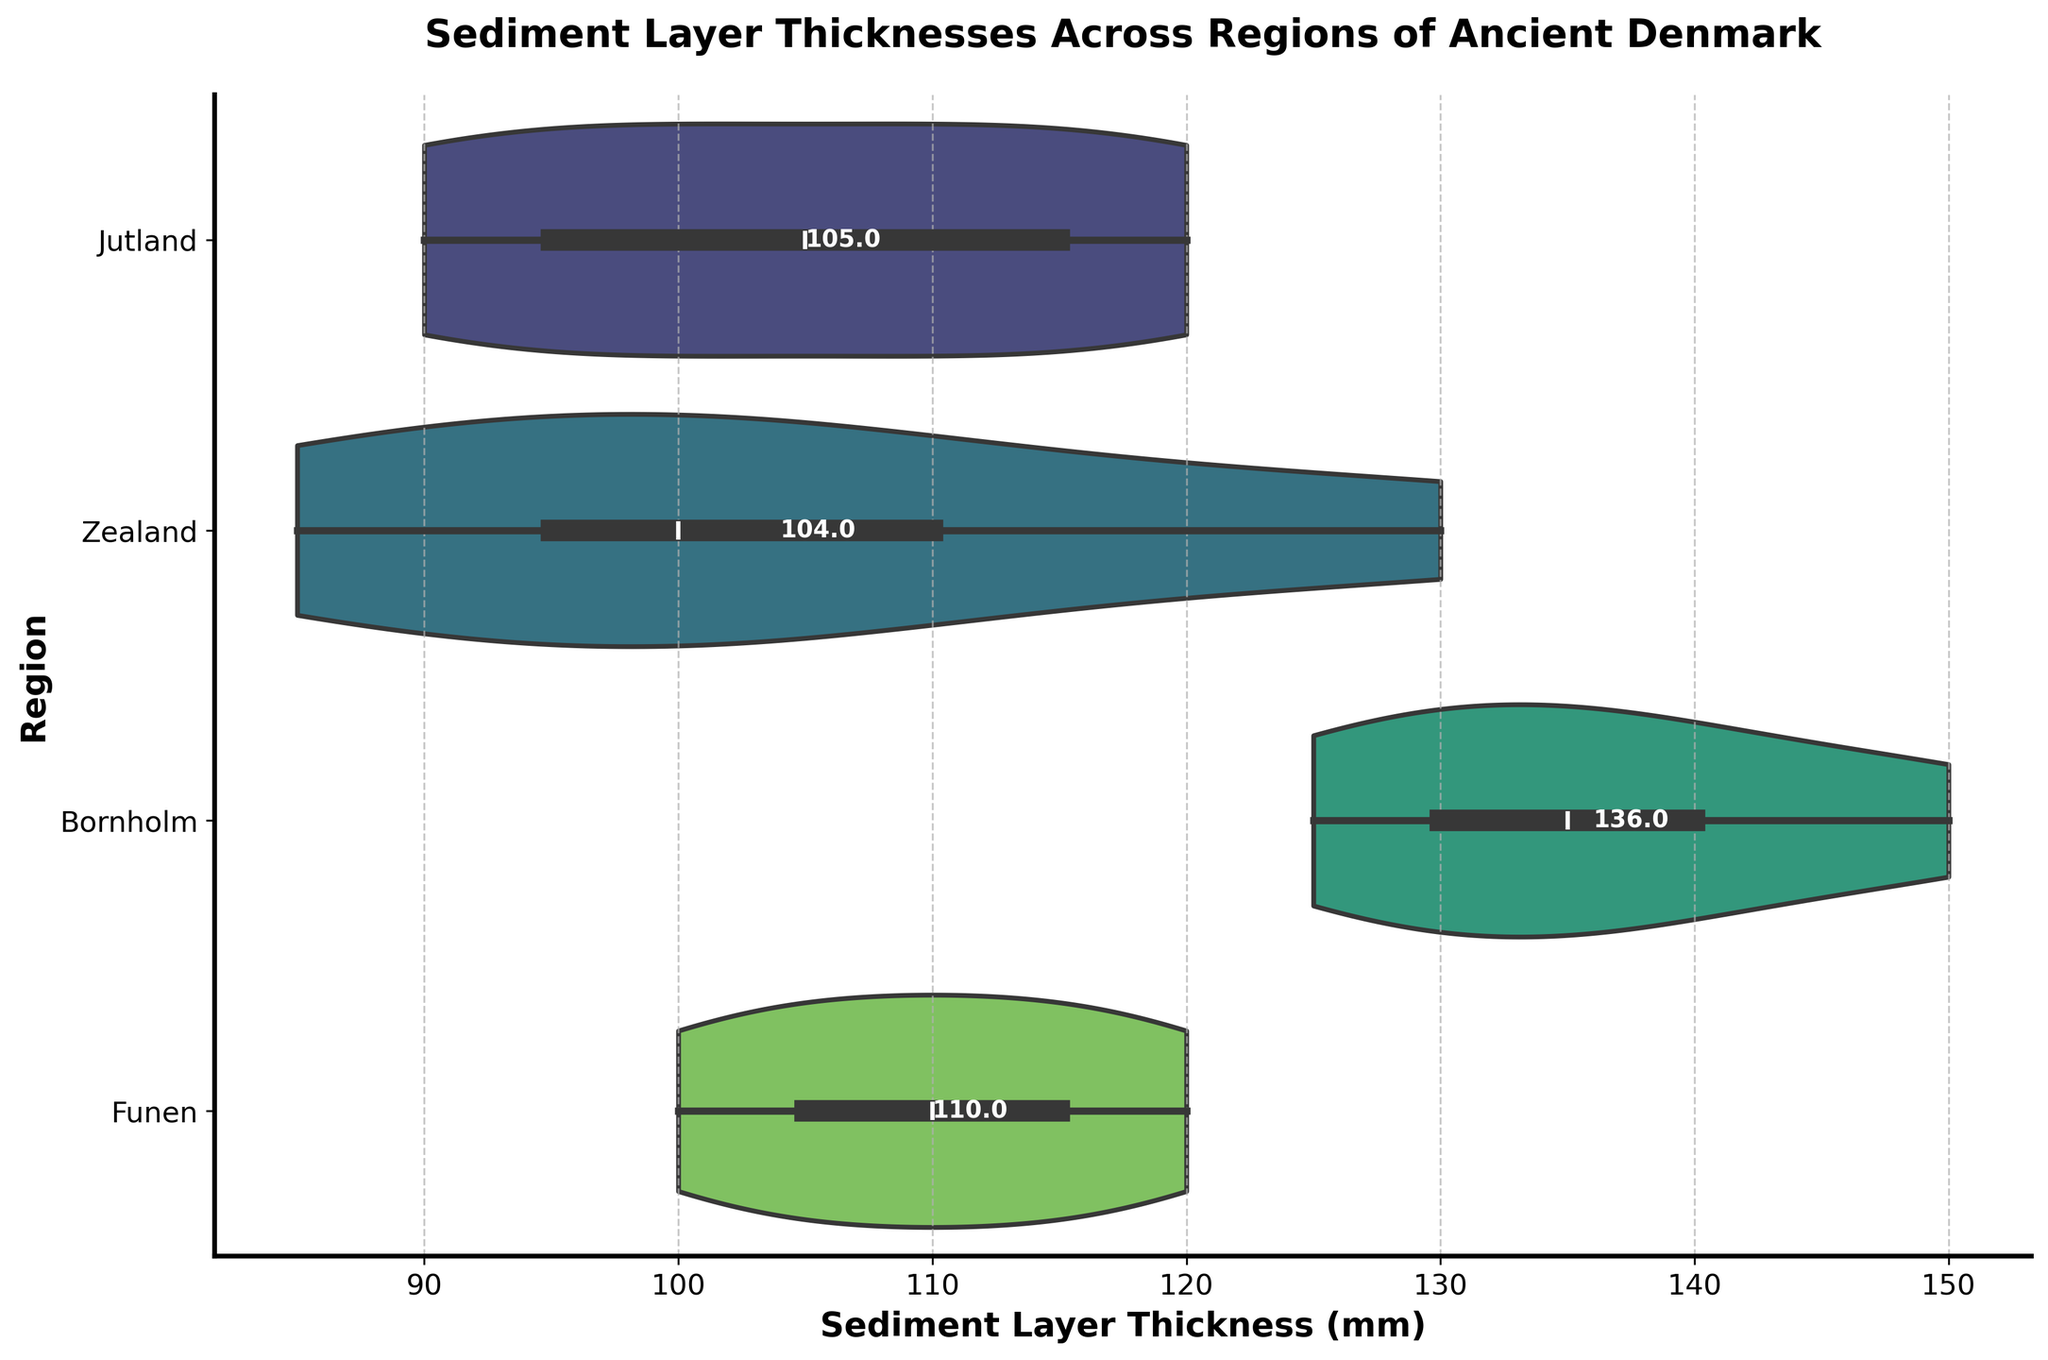What is the title of the figure? The title is displayed at the top of the figure in a larger and bold font. It describes the main topic of the chart.
Answer: Sediment Layer Thicknesses Across Regions of Ancient Denmark Which region has the highest mean sediment layer thickness? By looking at the text annotations along the horizontal axis near the violins, we can find the mean values for each region and identify the highest one.
Answer: Bornholm How many regions are represented in the figure? The y-axis labels each region, allowing us to count them directly.
Answer: Four What is the approximate range of sediment layer thickness in Jutland? The width of the violin plot for Jutland covers the range of data points, from the minimum to the maximum values.
Answer: 90 mm to 120 mm Which region has the most spread (i.e., variability) in sediment layer thickness? The spread or variability can be estimated by looking at the widths of the violin plots; the wider the plot, the greater the variability.
Answer: Bornholm Compare the median sediment layer thickness between Funen and Zealand. Observe the central lines within the violins of Funen and Zealand, which represent the median values.
Answer: Funen has a higher median than Zealand What are the minimum sediment layer thicknesses observed across all regions? The minimum thickness for each region can be identified at the thinnest part of each violin on the leftmost side.
Answer: 85 mm What is the median sediment layer thickness in Zealand? The central white line within the violin for Zealand represents the median sediment layer thickness.
Answer: 97.5 mm Which region has the least mean sediment layer thickness, and what is its value? The text annotations along the horizontal axis indicate the mean values. Identify the region with the lowest annotated value.
Answer: Zealand, 104.0 mm Is there overlap in the range of sediment layer thickness between Funen and Jutland? By comparing the ranges of the extensions of the violin plots for Funen and Jutland, we can determine if there's any overlap.
Answer: Yes 